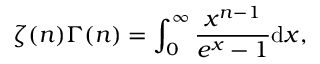<formula> <loc_0><loc_0><loc_500><loc_500>\zeta ( n ) { \Gamma ( n ) } = \int _ { 0 } ^ { \infty } { \frac { x ^ { n - 1 } } { e ^ { x } - 1 } } d x ,</formula> 